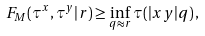Convert formula to latex. <formula><loc_0><loc_0><loc_500><loc_500>F _ { M } ( \tau ^ { x } , \tau ^ { y } | r ) \geq \inf _ { q \approx r } \tau ( | x y | q ) \, ,</formula> 